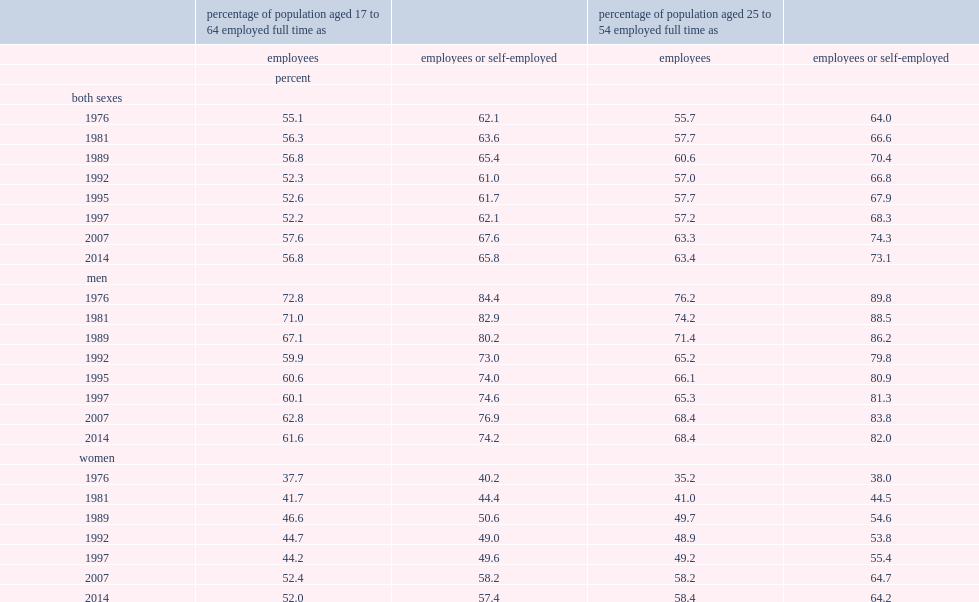How many percent of all individuals aged 17 to 64 who were not attending school full time were employed full time as employees or self-employed workers in 2014 and 1976 respectively? 65.8 62.1. 